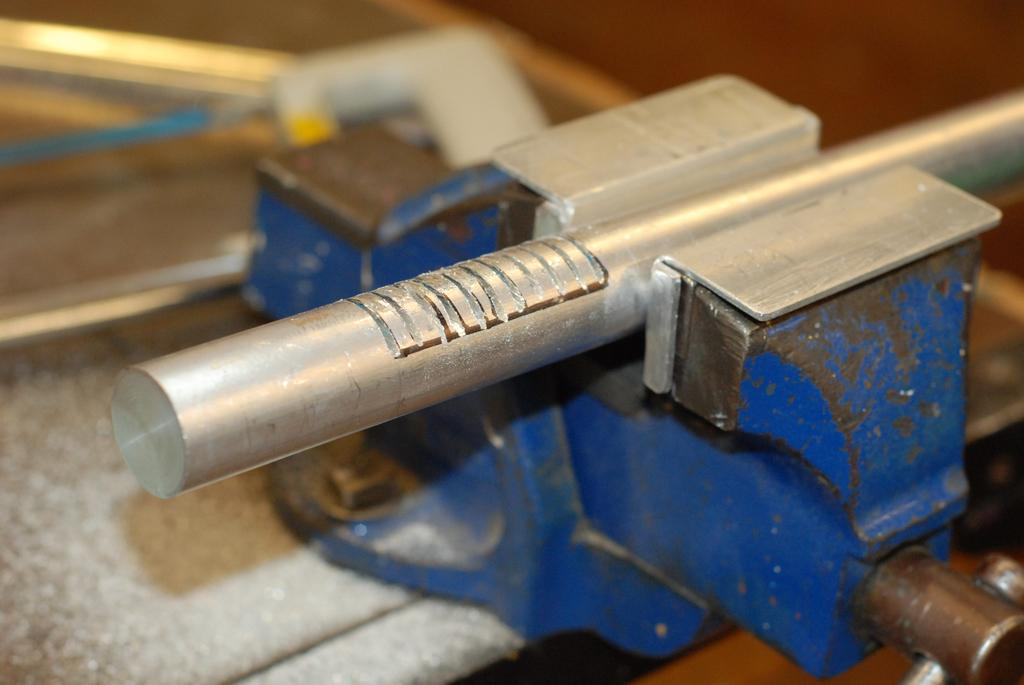What object can be seen on the right side of the image? There is a tool on the right side of the image. What is located in the middle of the image? There is an iron rod in the middle of the image. What type of flowers can be seen growing on the tool in the image? There are no flowers present in the image, and the tool is not associated with any plant growth. 